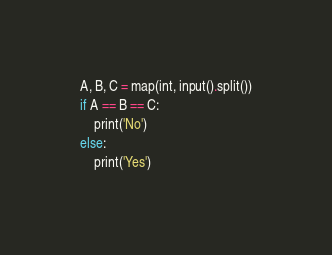<code> <loc_0><loc_0><loc_500><loc_500><_Python_>A, B, C = map(int, input().split())
if A == B == C:
    print('No')
else:
    print('Yes')</code> 